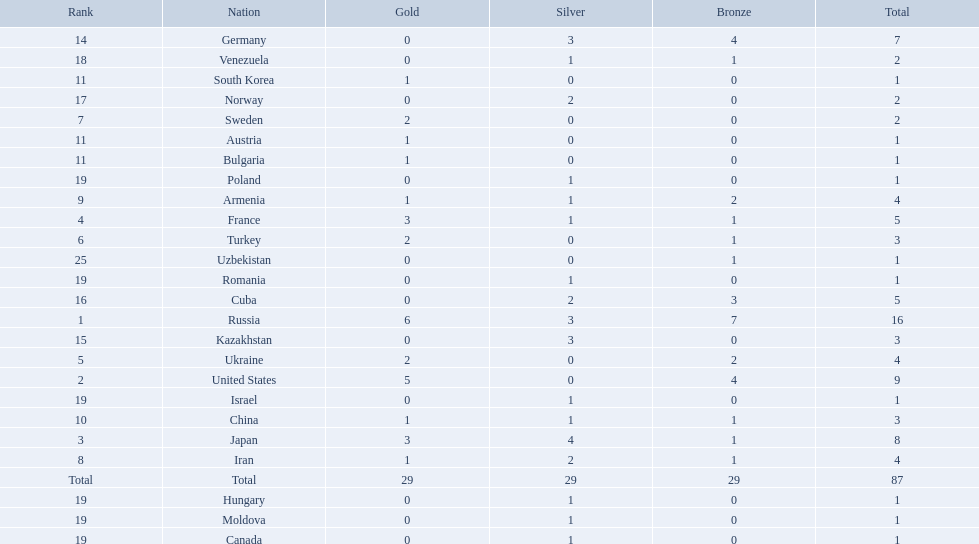What was iran's ranking? 8. What was germany's ranking? 14. Between iran and germany, which was not in the top 10? Germany. What nations have one gold medal? Iran, Armenia, China, Austria, Bulgaria, South Korea. Of these, which nations have zero silver medals? Austria, Bulgaria, South Korea. Of these, which nations also have zero bronze medals? Austria. 